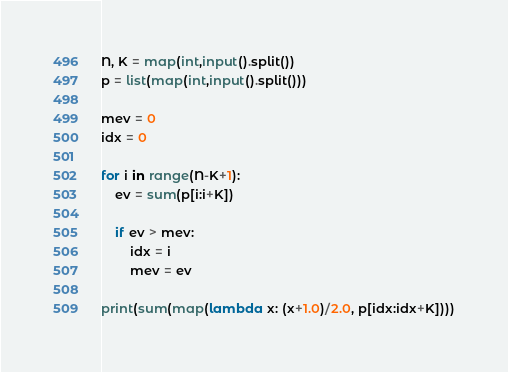Convert code to text. <code><loc_0><loc_0><loc_500><loc_500><_Python_>N, K = map(int,input().split())
p = list(map(int,input().split()))

mev = 0
idx = 0

for i in range(N-K+1):
    ev = sum(p[i:i+K])

    if ev > mev:
        idx = i
        mev = ev

print(sum(map(lambda x: (x+1.0)/2.0, p[idx:idx+K])))

</code> 